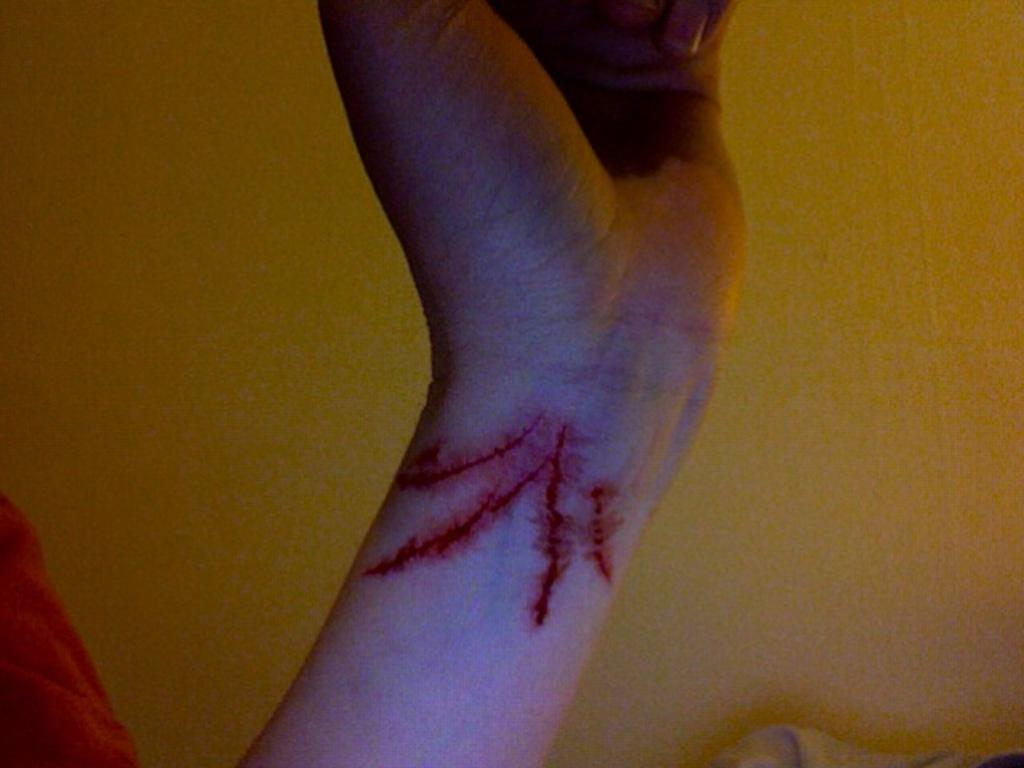What part of a person's body is visible in the image? There is a person's hand in the image. What type of structure can be seen in the background of the image? There is a wall in the image. How many boats are visible in the image? There are no boats present in the image. What type of planes can be seen flying in the image? There are no planes visible in the image. 